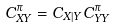Convert formula to latex. <formula><loc_0><loc_0><loc_500><loc_500>C _ { X Y } ^ { \pi } = C _ { X | Y } C _ { Y Y } ^ { \pi }</formula> 